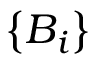Convert formula to latex. <formula><loc_0><loc_0><loc_500><loc_500>\left \{ B _ { i } \right \}</formula> 